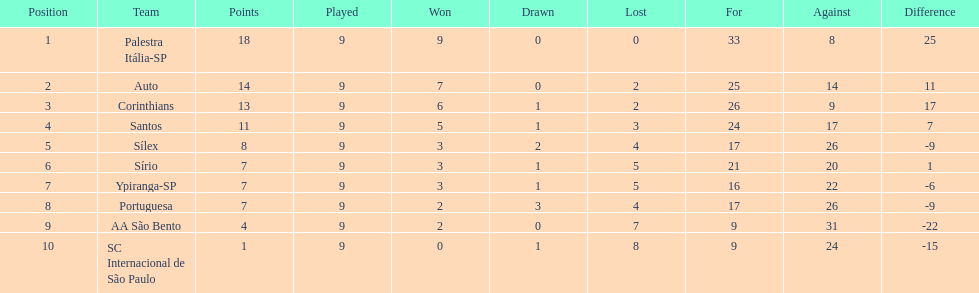Which brazilian team took the top spot in the 1926 brazilian football cup? Palestra Itália-SP. 